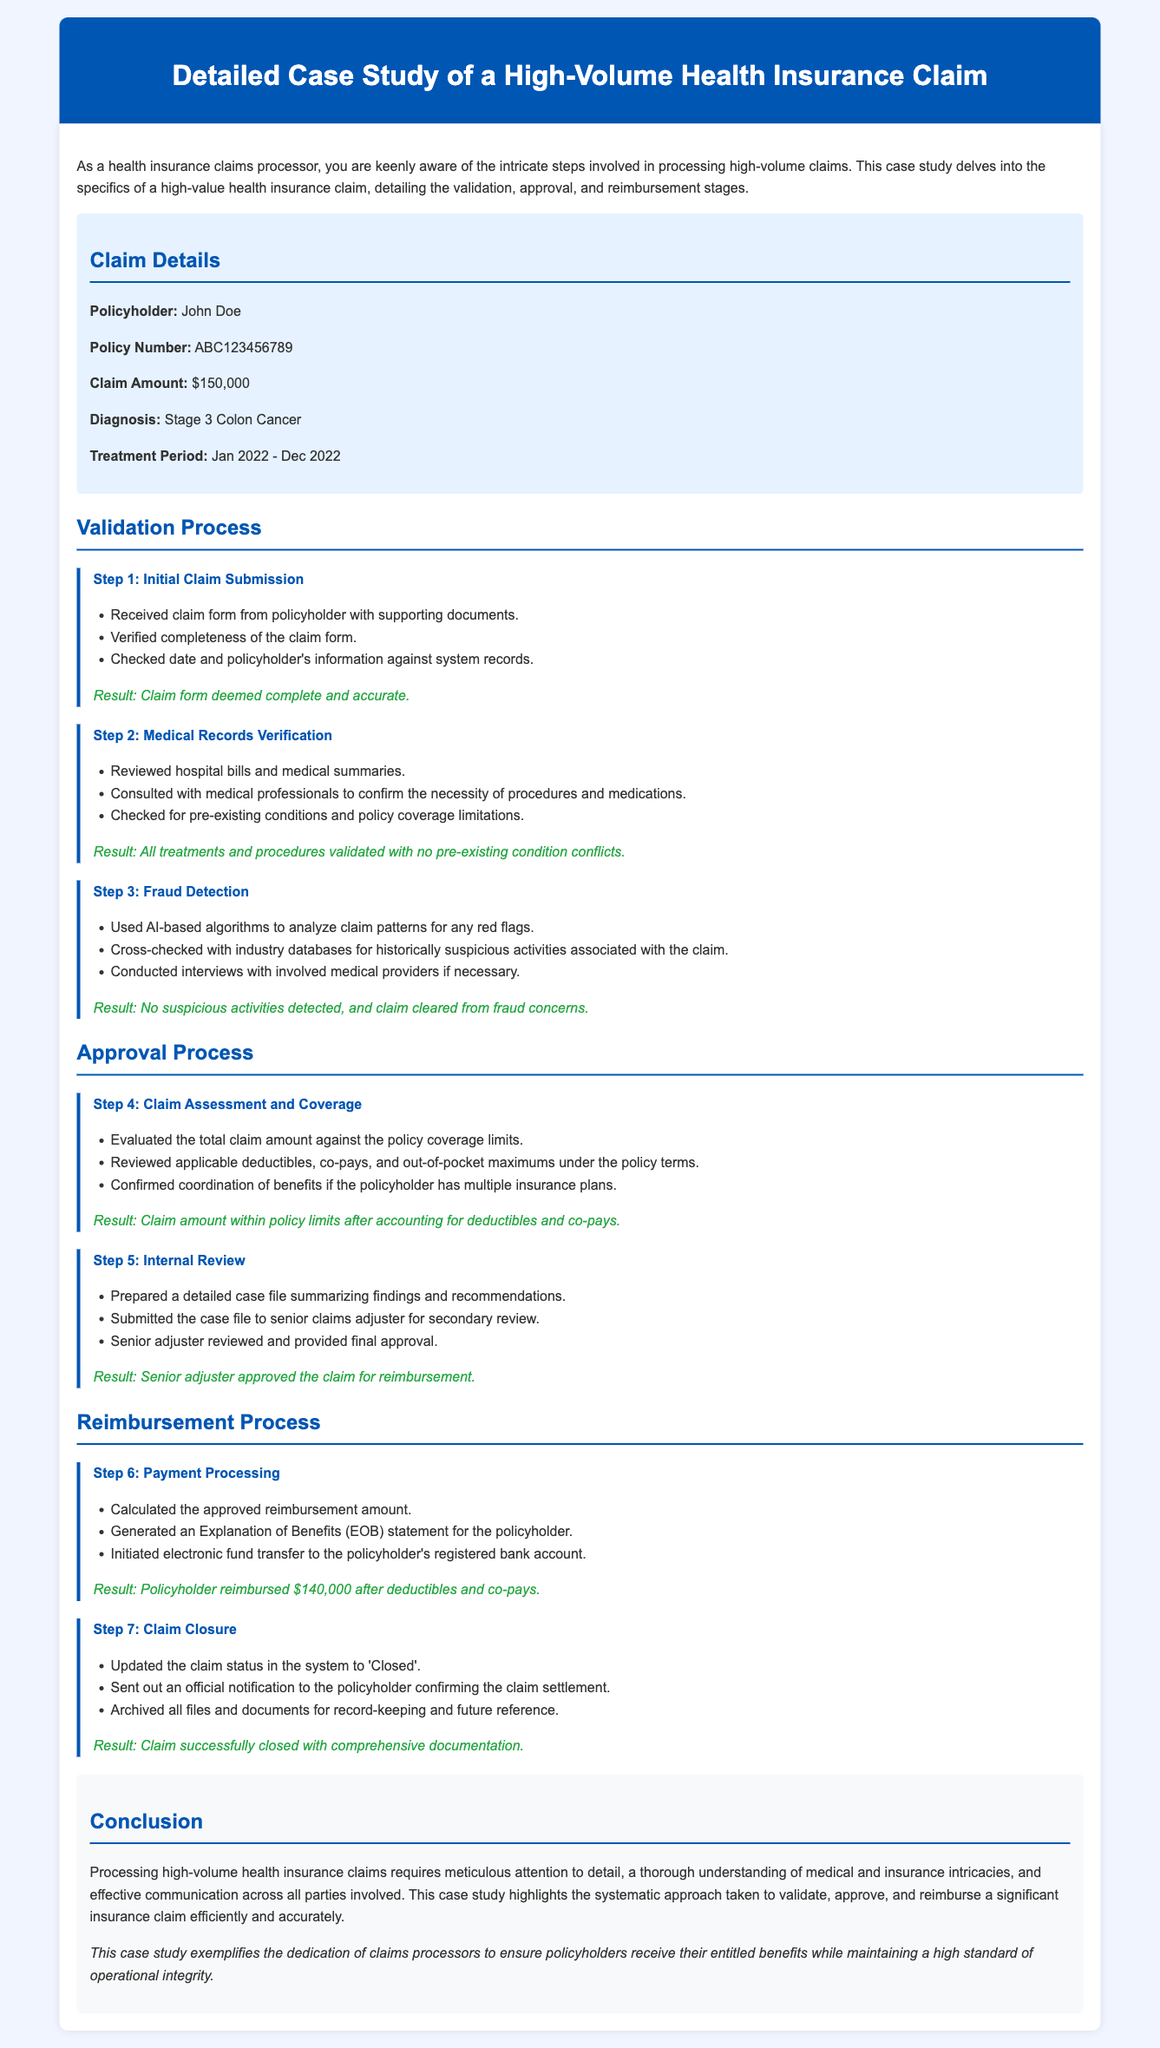What is the claim amount? The claim amount is stated in the document as $150,000.
Answer: $150,000 Who is the policyholder? The document specifies that the policyholder is John Doe.
Answer: John Doe What is the diagnosis for the claim? The diagnosis for the claim is provided as Stage 3 Colon Cancer.
Answer: Stage 3 Colon Cancer What was the treatment period? The treatment period is outlined as January 2022 to December 2022.
Answer: Jan 2022 - Dec 2022 What was the approved reimbursement amount after deductions? The document mentions that the policyholder was reimbursed $140,000 after deductions.
Answer: $140,000 What step involves the initial claim submission? The first step in the validation process concerning the initial claim submission is described clearly in the document.
Answer: Step 1 How many steps are there in the validation process? The document lists three specific steps in the validation process before moving to approval.
Answer: 3 What does EOB stand for in the reimbursement process? The document explains that EOB refers to the Explanation of Benefits provided to the policyholder.
Answer: Explanation of Benefits Which section discusses fraud detection? The section that describes fraud detection is under the validation process, specifically referred to as Step 3.
Answer: Step 3 Who provides the final approval of the claim? The final approval of the claim is given by a senior claims adjuster, as stated in the approval process section.
Answer: Senior claims adjuster 